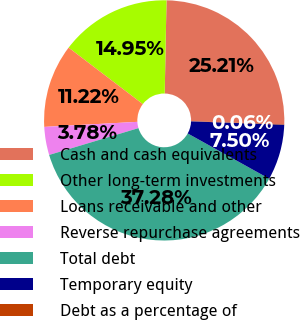Convert chart. <chart><loc_0><loc_0><loc_500><loc_500><pie_chart><fcel>Cash and cash equivalents<fcel>Other long-term investments<fcel>Loans receivable and other<fcel>Reverse repurchase agreements<fcel>Total debt<fcel>Temporary equity<fcel>Debt as a percentage of<nl><fcel>25.21%<fcel>14.95%<fcel>11.22%<fcel>3.78%<fcel>37.28%<fcel>7.5%<fcel>0.06%<nl></chart> 